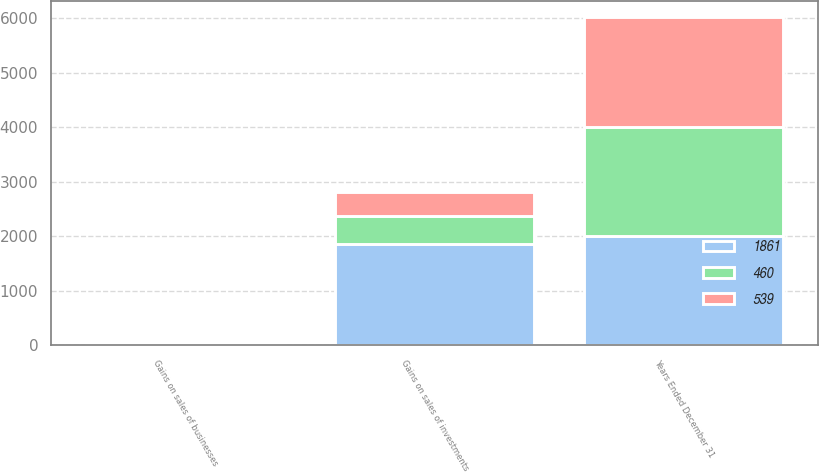Convert chart. <chart><loc_0><loc_0><loc_500><loc_500><stacked_bar_chart><ecel><fcel>Years Ended December 31<fcel>Gains on sales of investments<fcel>Gains on sales of businesses<nl><fcel>1861<fcel>2005<fcel>1848<fcel>13<nl><fcel>539<fcel>2004<fcel>434<fcel>26<nl><fcel>460<fcel>2003<fcel>524<fcel>15<nl></chart> 